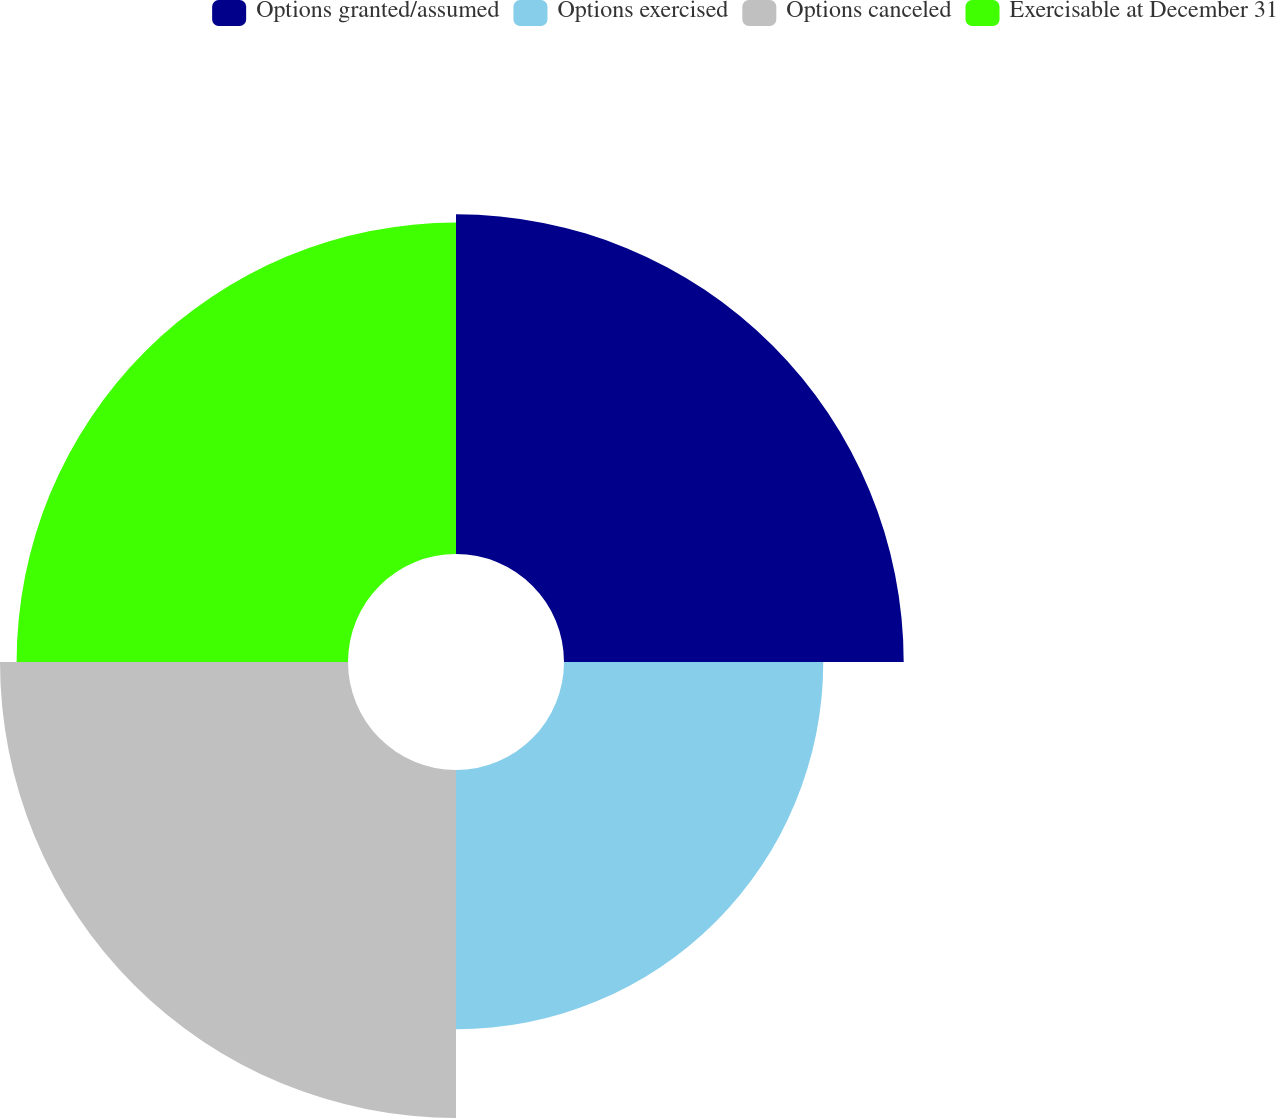Convert chart to OTSL. <chart><loc_0><loc_0><loc_500><loc_500><pie_chart><fcel>Options granted/assumed<fcel>Options exercised<fcel>Options canceled<fcel>Exercisable at December 31<nl><fcel>26.57%<fcel>20.28%<fcel>27.22%<fcel>25.92%<nl></chart> 